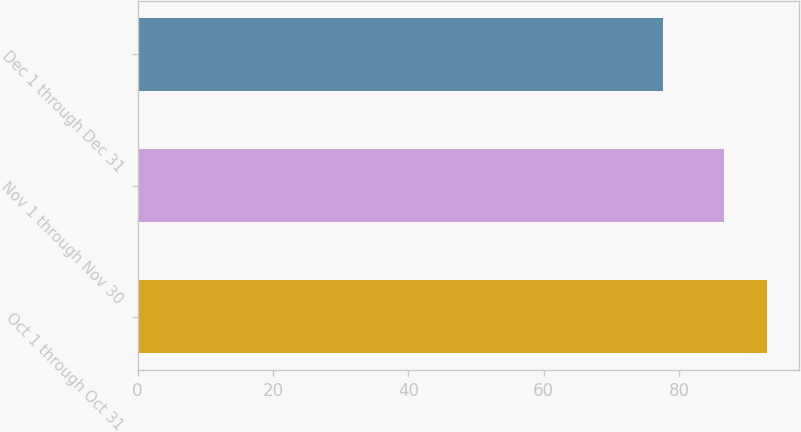<chart> <loc_0><loc_0><loc_500><loc_500><bar_chart><fcel>Oct 1 through Oct 31<fcel>Nov 1 through Nov 30<fcel>Dec 1 through Dec 31<nl><fcel>92.98<fcel>86.61<fcel>77.63<nl></chart> 